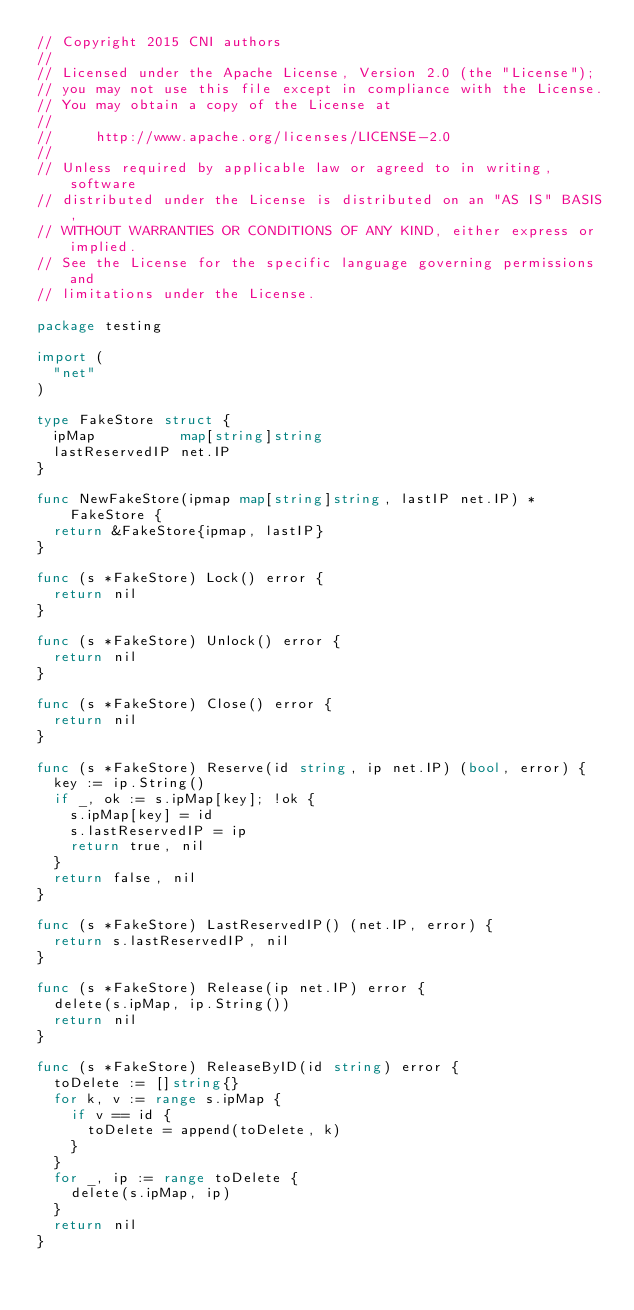<code> <loc_0><loc_0><loc_500><loc_500><_Go_>// Copyright 2015 CNI authors
//
// Licensed under the Apache License, Version 2.0 (the "License");
// you may not use this file except in compliance with the License.
// You may obtain a copy of the License at
//
//     http://www.apache.org/licenses/LICENSE-2.0
//
// Unless required by applicable law or agreed to in writing, software
// distributed under the License is distributed on an "AS IS" BASIS,
// WITHOUT WARRANTIES OR CONDITIONS OF ANY KIND, either express or implied.
// See the License for the specific language governing permissions and
// limitations under the License.

package testing

import (
	"net"
)

type FakeStore struct {
	ipMap          map[string]string
	lastReservedIP net.IP
}

func NewFakeStore(ipmap map[string]string, lastIP net.IP) *FakeStore {
	return &FakeStore{ipmap, lastIP}
}

func (s *FakeStore) Lock() error {
	return nil
}

func (s *FakeStore) Unlock() error {
	return nil
}

func (s *FakeStore) Close() error {
	return nil
}

func (s *FakeStore) Reserve(id string, ip net.IP) (bool, error) {
	key := ip.String()
	if _, ok := s.ipMap[key]; !ok {
		s.ipMap[key] = id
		s.lastReservedIP = ip
		return true, nil
	}
	return false, nil
}

func (s *FakeStore) LastReservedIP() (net.IP, error) {
	return s.lastReservedIP, nil
}

func (s *FakeStore) Release(ip net.IP) error {
	delete(s.ipMap, ip.String())
	return nil
}

func (s *FakeStore) ReleaseByID(id string) error {
	toDelete := []string{}
	for k, v := range s.ipMap {
		if v == id {
			toDelete = append(toDelete, k)
		}
	}
	for _, ip := range toDelete {
		delete(s.ipMap, ip)
	}
	return nil
}
</code> 